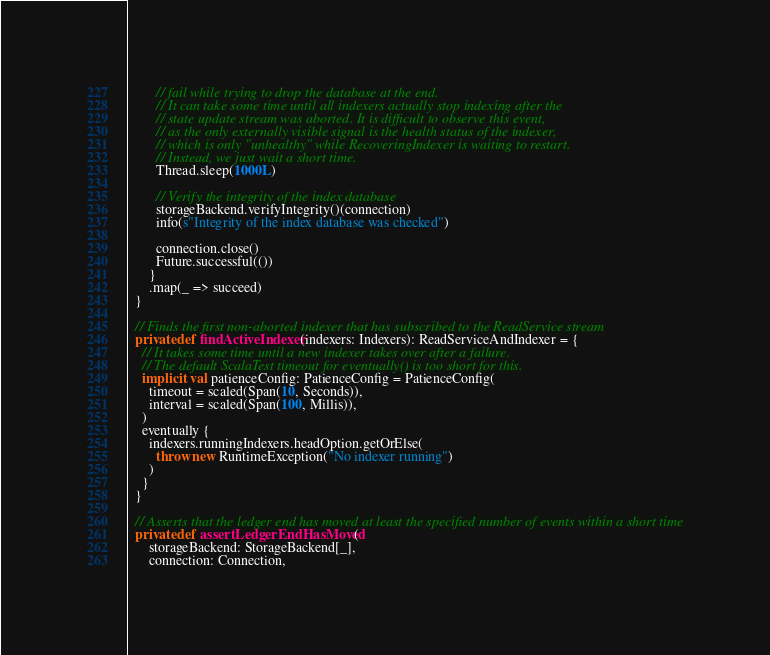Convert code to text. <code><loc_0><loc_0><loc_500><loc_500><_Scala_>        // fail while trying to drop the database at the end.
        // It can take some time until all indexers actually stop indexing after the
        // state update stream was aborted. It is difficult to observe this event,
        // as the only externally visible signal is the health status of the indexer,
        // which is only "unhealthy" while RecoveringIndexer is waiting to restart.
        // Instead, we just wait a short time.
        Thread.sleep(1000L)

        // Verify the integrity of the index database
        storageBackend.verifyIntegrity()(connection)
        info(s"Integrity of the index database was checked")

        connection.close()
        Future.successful(())
      }
      .map(_ => succeed)
  }

  // Finds the first non-aborted indexer that has subscribed to the ReadService stream
  private def findActiveIndexer(indexers: Indexers): ReadServiceAndIndexer = {
    // It takes some time until a new indexer takes over after a failure.
    // The default ScalaTest timeout for eventually() is too short for this.
    implicit val patienceConfig: PatienceConfig = PatienceConfig(
      timeout = scaled(Span(10, Seconds)),
      interval = scaled(Span(100, Millis)),
    )
    eventually {
      indexers.runningIndexers.headOption.getOrElse(
        throw new RuntimeException("No indexer running")
      )
    }
  }

  // Asserts that the ledger end has moved at least the specified number of events within a short time
  private def assertLedgerEndHasMoved(
      storageBackend: StorageBackend[_],
      connection: Connection,</code> 